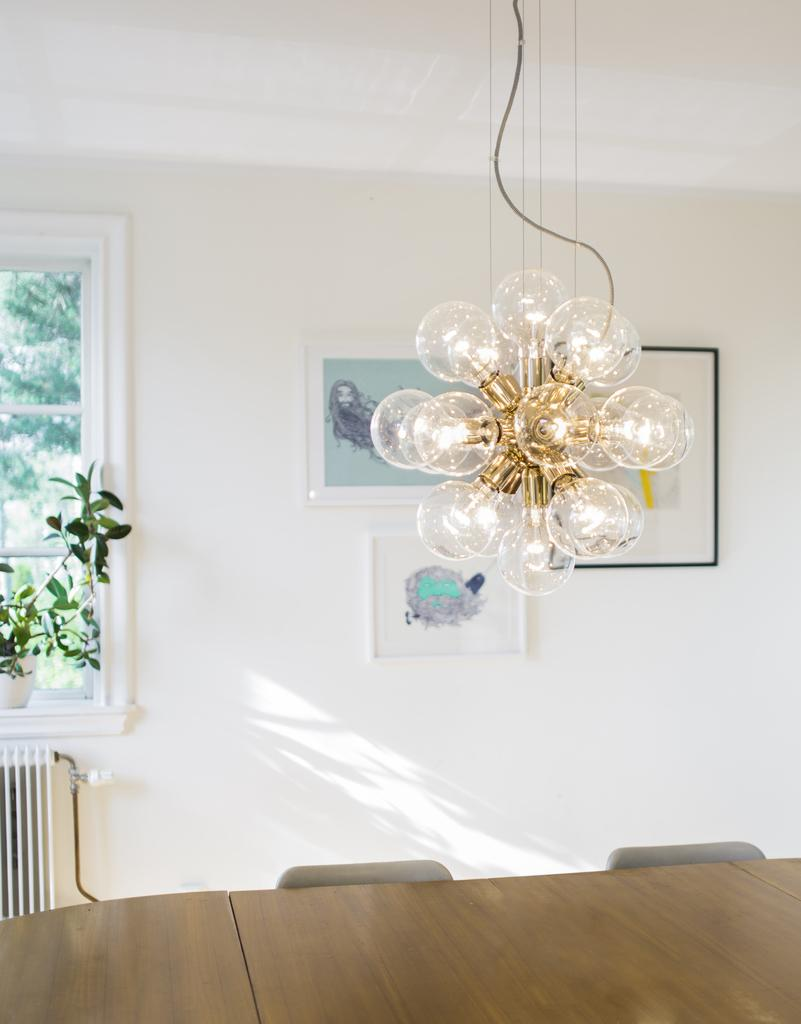What type of lighting fixture is present in the room? There is a chandelier in the room. Where is the chandelier located in relation to the roof? The chandelier is near the roof. What type of plant can be seen in the room? There is a plant in a pot in the room. Where is the plant placed in the room? The plant is placed beside a window. What type of decoration is present on the wall in the room? There are photo frames on a wall in the room. What type of furniture is present in the room? There is a table and chairs in the room. What type of science experiment is being conducted with the fowl in the room? There is no fowl present in the room, and therefore no such experiment can be observed. How many wings are visible on the chandelier in the room? The chandelier does not have wings; it is a lighting fixture. 